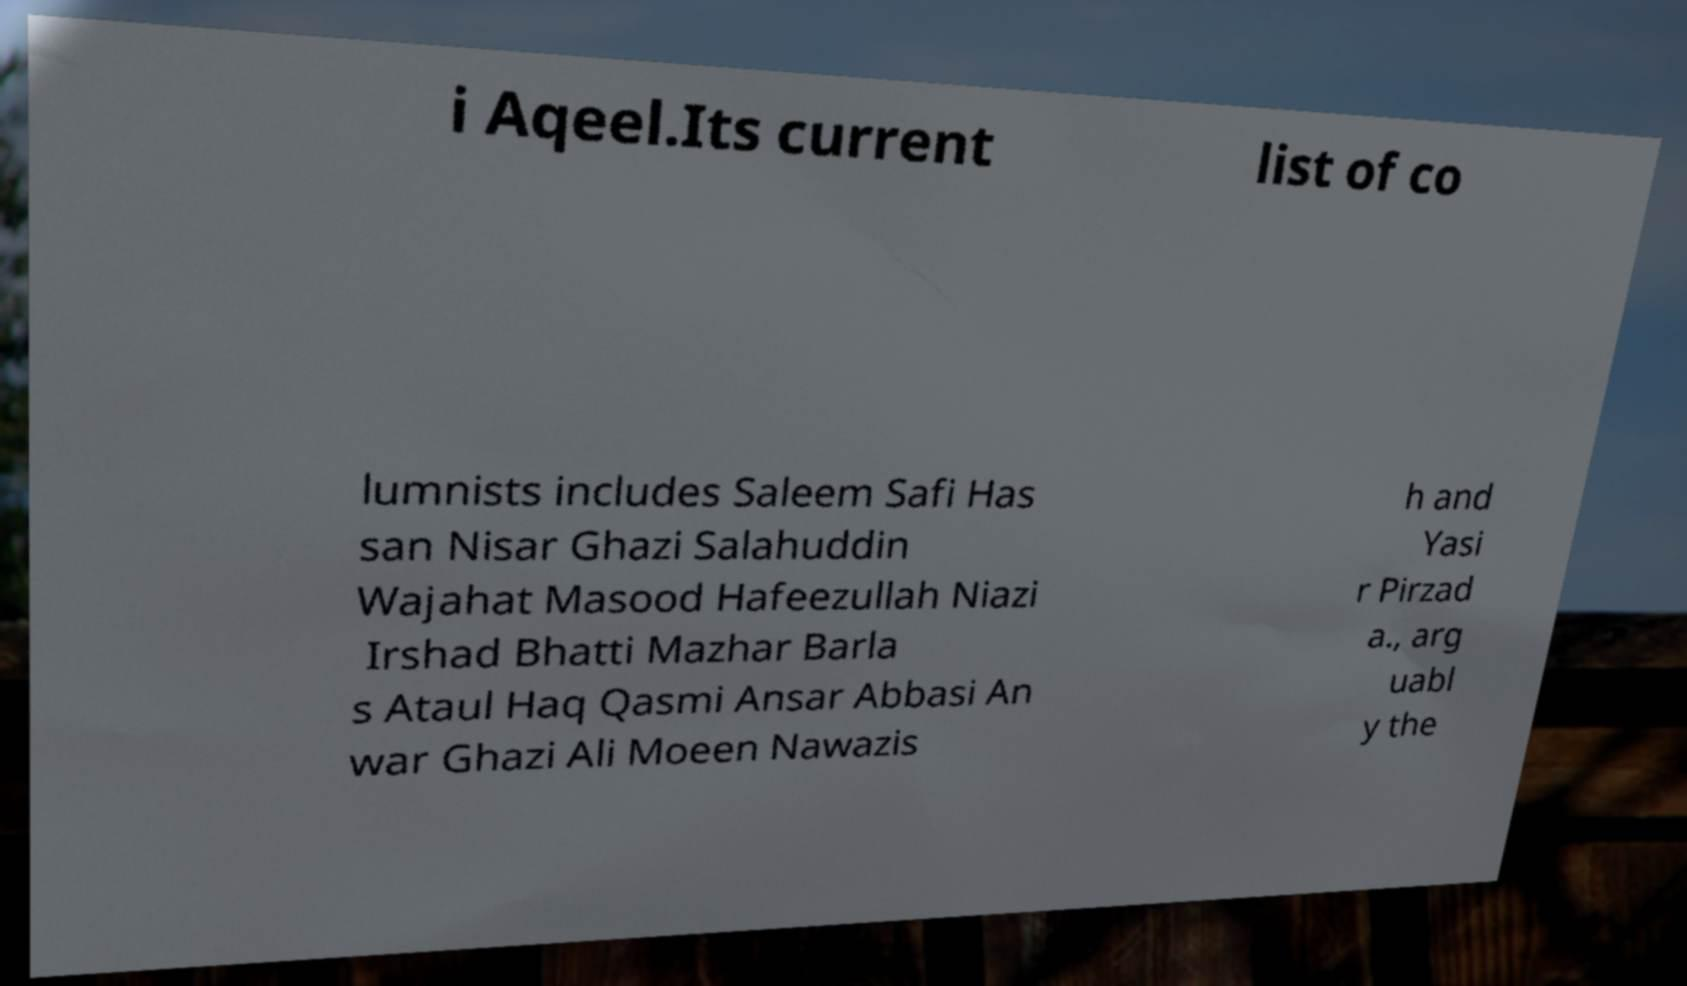I need the written content from this picture converted into text. Can you do that? i Aqeel.Its current list of co lumnists includes Saleem Safi Has san Nisar Ghazi Salahuddin Wajahat Masood Hafeezullah Niazi Irshad Bhatti Mazhar Barla s Ataul Haq Qasmi Ansar Abbasi An war Ghazi Ali Moeen Nawazis h and Yasi r Pirzad a., arg uabl y the 